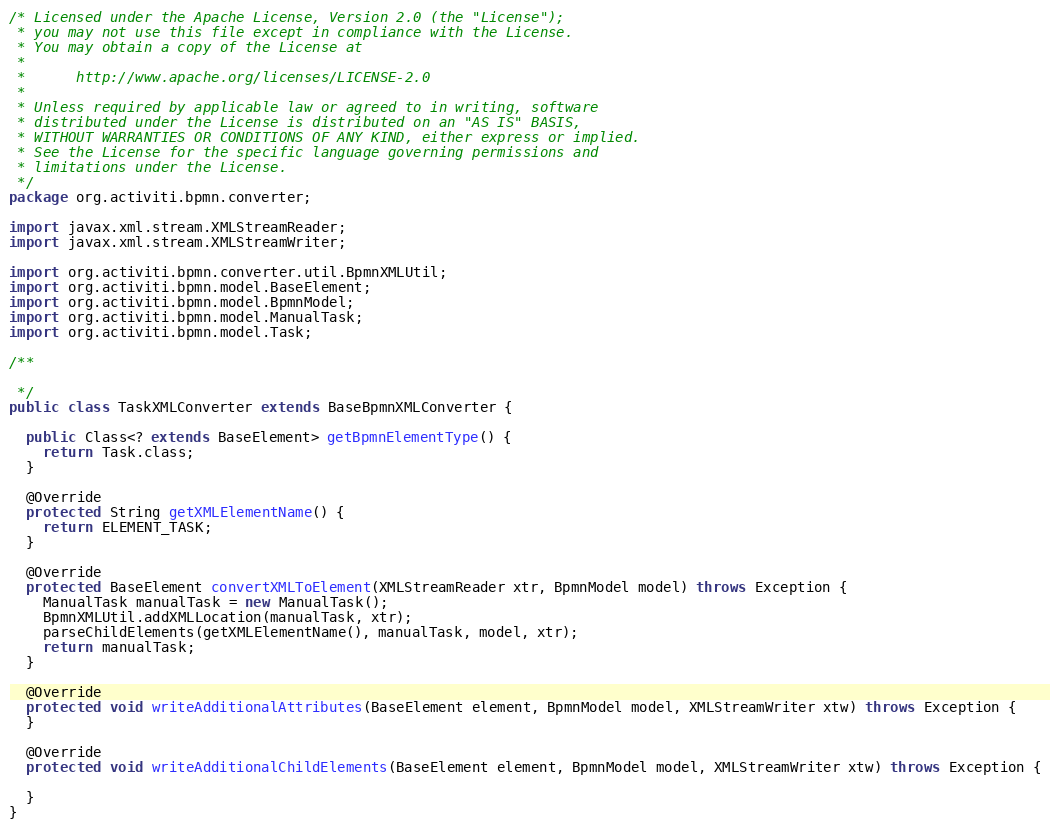<code> <loc_0><loc_0><loc_500><loc_500><_Java_>/* Licensed under the Apache License, Version 2.0 (the "License");
 * you may not use this file except in compliance with the License.
 * You may obtain a copy of the License at
 * 
 *      http://www.apache.org/licenses/LICENSE-2.0
 * 
 * Unless required by applicable law or agreed to in writing, software
 * distributed under the License is distributed on an "AS IS" BASIS,
 * WITHOUT WARRANTIES OR CONDITIONS OF ANY KIND, either express or implied.
 * See the License for the specific language governing permissions and
 * limitations under the License.
 */
package org.activiti.bpmn.converter;

import javax.xml.stream.XMLStreamReader;
import javax.xml.stream.XMLStreamWriter;

import org.activiti.bpmn.converter.util.BpmnXMLUtil;
import org.activiti.bpmn.model.BaseElement;
import org.activiti.bpmn.model.BpmnModel;
import org.activiti.bpmn.model.ManualTask;
import org.activiti.bpmn.model.Task;

/**

 */
public class TaskXMLConverter extends BaseBpmnXMLConverter {

  public Class<? extends BaseElement> getBpmnElementType() {
    return Task.class;
  }

  @Override
  protected String getXMLElementName() {
    return ELEMENT_TASK;
  }

  @Override
  protected BaseElement convertXMLToElement(XMLStreamReader xtr, BpmnModel model) throws Exception {
    ManualTask manualTask = new ManualTask();
    BpmnXMLUtil.addXMLLocation(manualTask, xtr);
    parseChildElements(getXMLElementName(), manualTask, model, xtr);
    return manualTask;
  }

  @Override
  protected void writeAdditionalAttributes(BaseElement element, BpmnModel model, XMLStreamWriter xtw) throws Exception {
  }

  @Override
  protected void writeAdditionalChildElements(BaseElement element, BpmnModel model, XMLStreamWriter xtw) throws Exception {

  }
}
</code> 